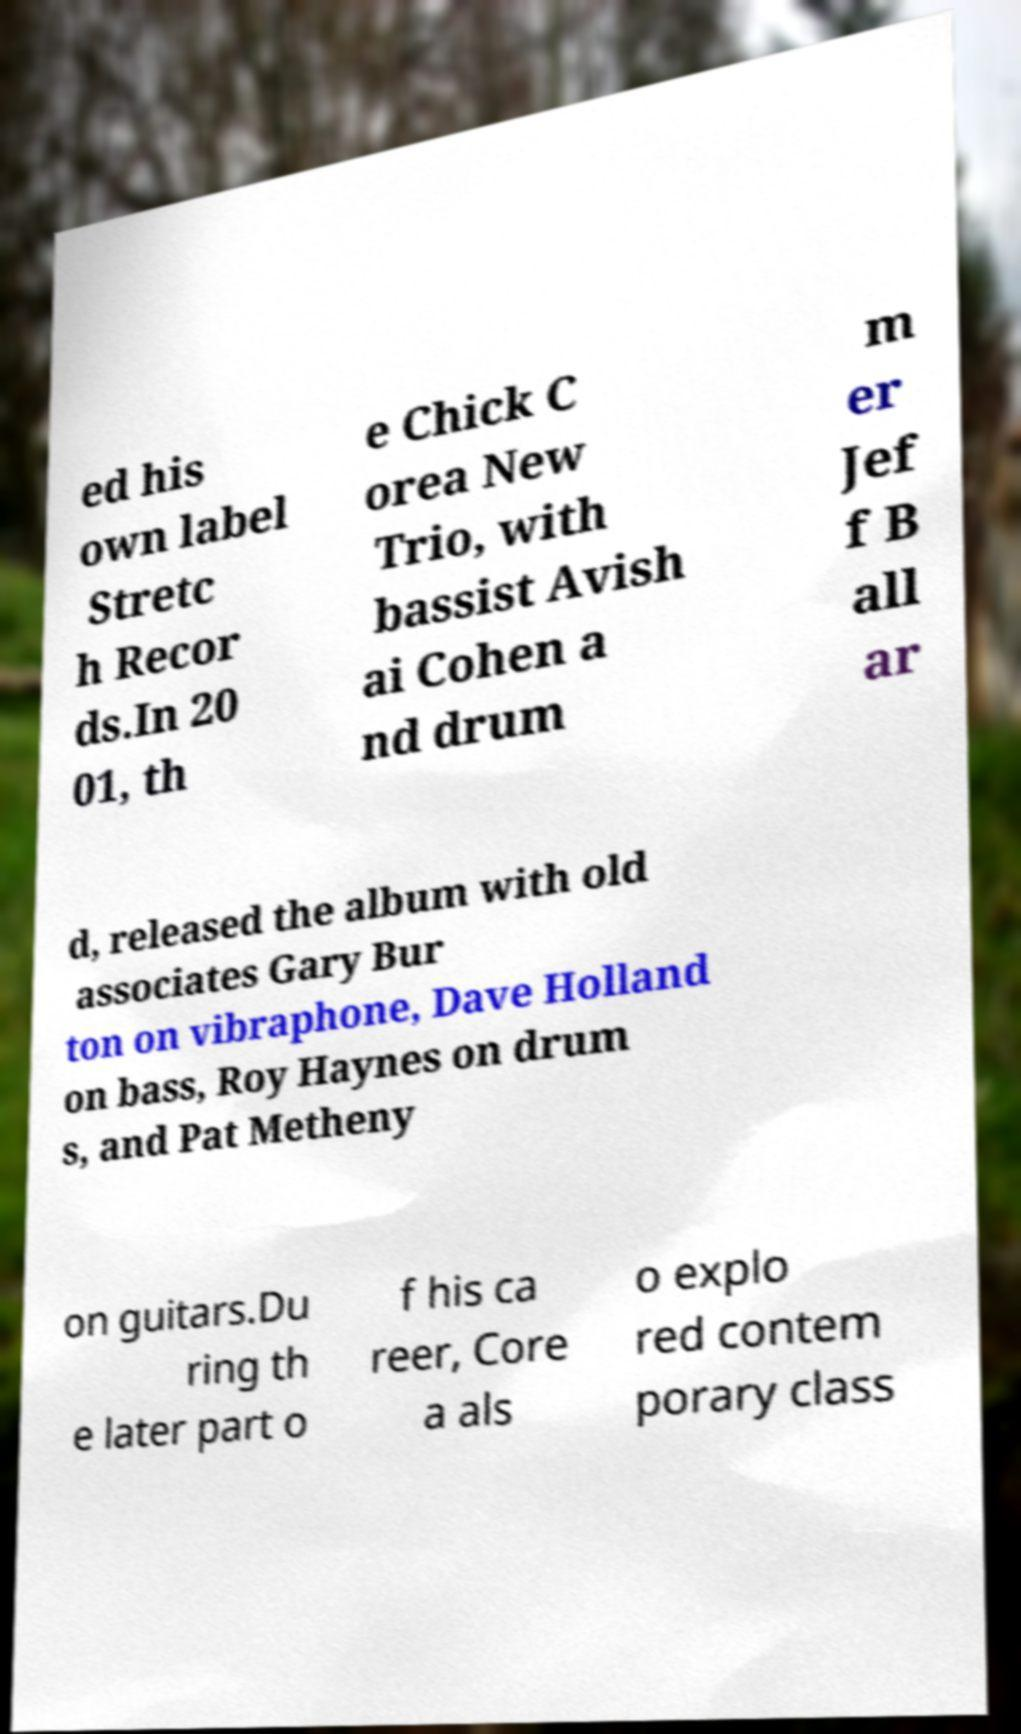For documentation purposes, I need the text within this image transcribed. Could you provide that? ed his own label Stretc h Recor ds.In 20 01, th e Chick C orea New Trio, with bassist Avish ai Cohen a nd drum m er Jef f B all ar d, released the album with old associates Gary Bur ton on vibraphone, Dave Holland on bass, Roy Haynes on drum s, and Pat Metheny on guitars.Du ring th e later part o f his ca reer, Core a als o explo red contem porary class 